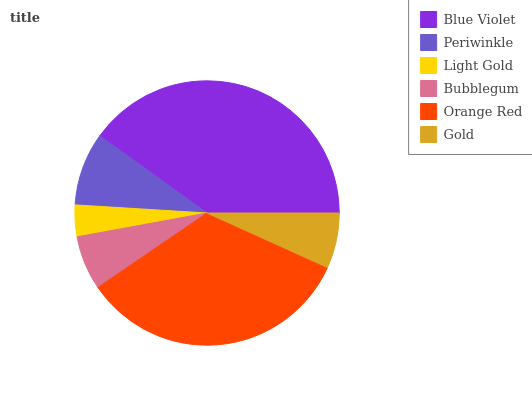Is Light Gold the minimum?
Answer yes or no. Yes. Is Blue Violet the maximum?
Answer yes or no. Yes. Is Periwinkle the minimum?
Answer yes or no. No. Is Periwinkle the maximum?
Answer yes or no. No. Is Blue Violet greater than Periwinkle?
Answer yes or no. Yes. Is Periwinkle less than Blue Violet?
Answer yes or no. Yes. Is Periwinkle greater than Blue Violet?
Answer yes or no. No. Is Blue Violet less than Periwinkle?
Answer yes or no. No. Is Periwinkle the high median?
Answer yes or no. Yes. Is Gold the low median?
Answer yes or no. Yes. Is Light Gold the high median?
Answer yes or no. No. Is Periwinkle the low median?
Answer yes or no. No. 